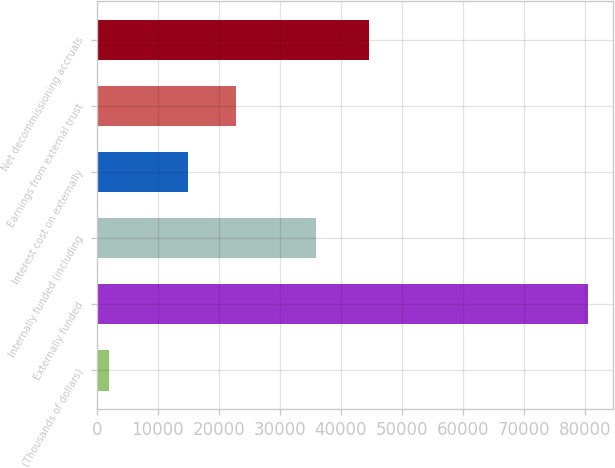<chart> <loc_0><loc_0><loc_500><loc_500><bar_chart><fcel>(Thousands of dollars)<fcel>Externally funded<fcel>Internally funded (including<fcel>Interest cost on externally<fcel>Earnings from external trust<fcel>Net decommissioning accruals<nl><fcel>2003<fcel>80582<fcel>35906<fcel>14952<fcel>22809.9<fcel>44676<nl></chart> 